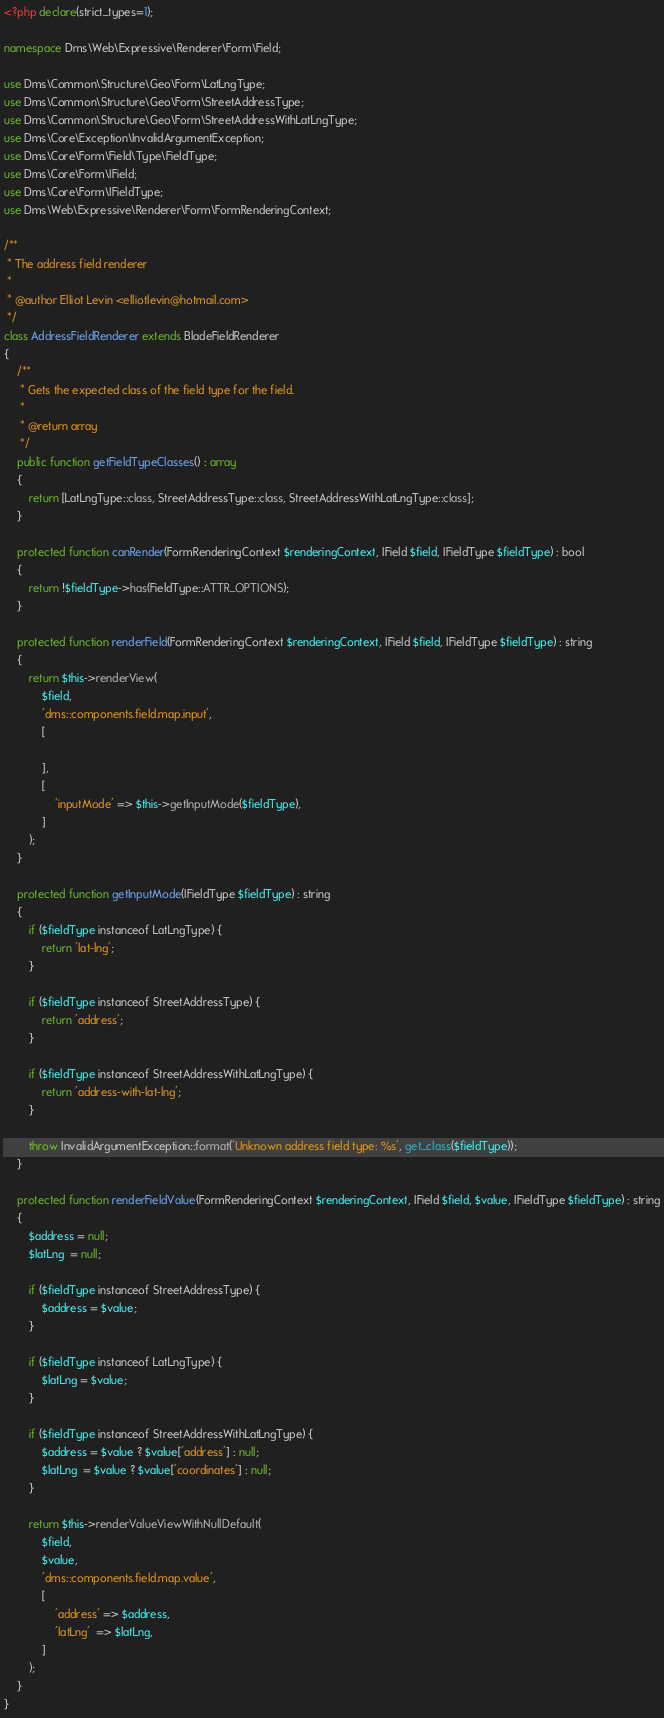Convert code to text. <code><loc_0><loc_0><loc_500><loc_500><_PHP_><?php declare(strict_types=1);

namespace Dms\Web\Expressive\Renderer\Form\Field;

use Dms\Common\Structure\Geo\Form\LatLngType;
use Dms\Common\Structure\Geo\Form\StreetAddressType;
use Dms\Common\Structure\Geo\Form\StreetAddressWithLatLngType;
use Dms\Core\Exception\InvalidArgumentException;
use Dms\Core\Form\Field\Type\FieldType;
use Dms\Core\Form\IField;
use Dms\Core\Form\IFieldType;
use Dms\Web\Expressive\Renderer\Form\FormRenderingContext;

/**
 * The address field renderer
 *
 * @author Elliot Levin <elliotlevin@hotmail.com>
 */
class AddressFieldRenderer extends BladeFieldRenderer
{
    /**
     * Gets the expected class of the field type for the field.
     *
     * @return array
     */
    public function getFieldTypeClasses() : array
    {
        return [LatLngType::class, StreetAddressType::class, StreetAddressWithLatLngType::class];
    }

    protected function canRender(FormRenderingContext $renderingContext, IField $field, IFieldType $fieldType) : bool
    {
        return !$fieldType->has(FieldType::ATTR_OPTIONS);
    }

    protected function renderField(FormRenderingContext $renderingContext, IField $field, IFieldType $fieldType) : string
    {
        return $this->renderView(
            $field,
            'dms::components.field.map.input',
            [

            ],
            [
                'inputMode' => $this->getInputMode($fieldType),
            ]
        );
    }

    protected function getInputMode(IFieldType $fieldType) : string
    {
        if ($fieldType instanceof LatLngType) {
            return 'lat-lng';
        }

        if ($fieldType instanceof StreetAddressType) {
            return 'address';
        }

        if ($fieldType instanceof StreetAddressWithLatLngType) {
            return 'address-with-lat-lng';
        }

        throw InvalidArgumentException::format('Unknown address field type: %s', get_class($fieldType));
    }

    protected function renderFieldValue(FormRenderingContext $renderingContext, IField $field, $value, IFieldType $fieldType) : string
    {
        $address = null;
        $latLng  = null;

        if ($fieldType instanceof StreetAddressType) {
            $address = $value;
        }

        if ($fieldType instanceof LatLngType) {
            $latLng = $value;
        }

        if ($fieldType instanceof StreetAddressWithLatLngType) {
            $address = $value ? $value['address'] : null;
            $latLng  = $value ? $value['coordinates'] : null;
        }

        return $this->renderValueViewWithNullDefault(
            $field,
            $value,
            'dms::components.field.map.value',
            [
                'address' => $address,
                'latLng'  => $latLng,
            ]
        );
    }
}
</code> 